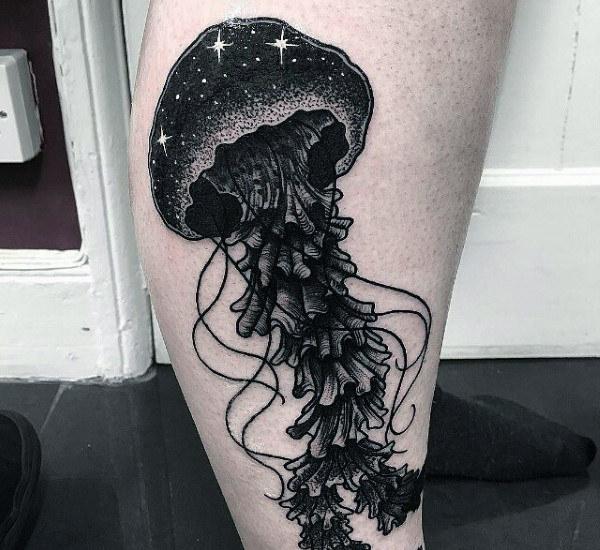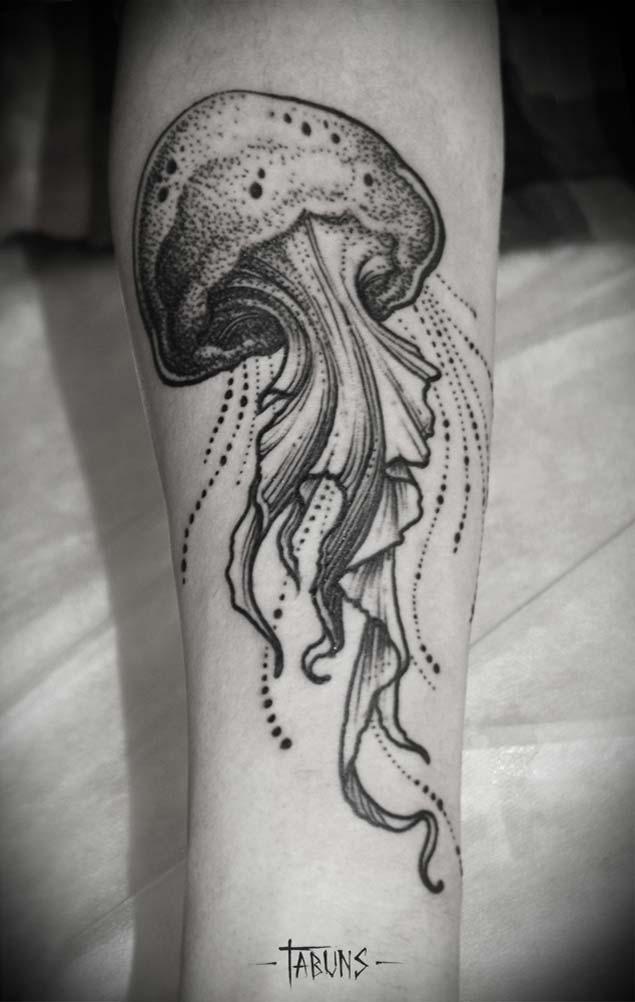The first image is the image on the left, the second image is the image on the right. For the images displayed, is the sentence "Right and left images show a non-color tattoo of a single large jellyfish with trailing tentacles on a human leg." factually correct? Answer yes or no. Yes. The first image is the image on the left, the second image is the image on the right. For the images shown, is this caption "Each image shows exactly one tattoo on a person's bare skin, each image an elaborate jelly fish design with long tendrils inked in black." true? Answer yes or no. Yes. 